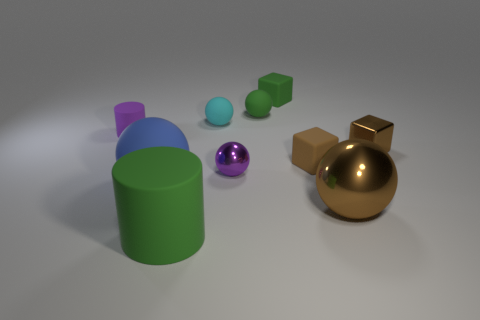There is a large brown object that is the same shape as the big blue matte object; what is it made of?
Your response must be concise. Metal. There is a tiny block that is the same color as the big cylinder; what is it made of?
Ensure brevity in your answer.  Rubber. There is a ball that is the same size as the blue object; what material is it?
Make the answer very short. Metal. What shape is the small purple object on the right side of the rubber cylinder that is behind the big rubber thing to the left of the big green thing?
Keep it short and to the point. Sphere. There is a tiny rubber cube that is behind the small rubber cylinder; is its color the same as the rubber cylinder that is right of the big blue matte object?
Ensure brevity in your answer.  Yes. How many tiny cyan matte cylinders are there?
Your response must be concise. 0. There is a purple matte thing; are there any brown rubber cubes on the left side of it?
Provide a succinct answer. No. Do the cylinder that is behind the big blue rubber ball and the large ball on the left side of the big cylinder have the same material?
Ensure brevity in your answer.  Yes. Are there fewer tiny brown matte cubes that are left of the tiny brown matte thing than large yellow metal cylinders?
Provide a short and direct response. No. What is the color of the cylinder on the right side of the blue matte thing?
Your response must be concise. Green. 